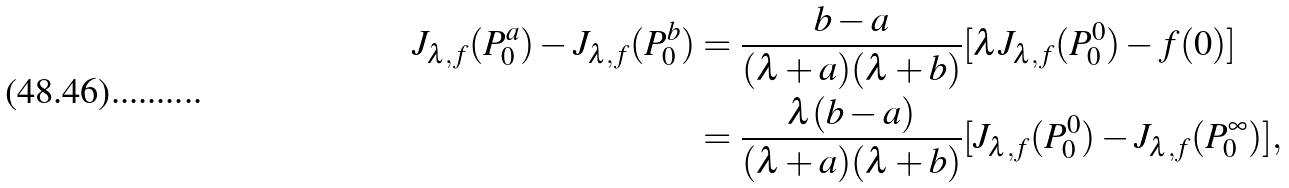<formula> <loc_0><loc_0><loc_500><loc_500>J _ { \lambda , f } ( P _ { 0 } ^ { a } ) - J _ { \lambda , f } ( P _ { 0 } ^ { b } ) & = \frac { b - a } { ( \lambda + a ) ( \lambda + b ) } [ \lambda J _ { \lambda , f } ( P _ { 0 } ^ { 0 } ) - f ( 0 ) ] \\ & = \frac { \lambda ( b - a ) } { ( \lambda + a ) ( \lambda + b ) } [ J _ { \lambda , f } ( P _ { 0 } ^ { 0 } ) - J _ { \lambda , f } ( P _ { 0 } ^ { \infty } ) ] ,</formula> 